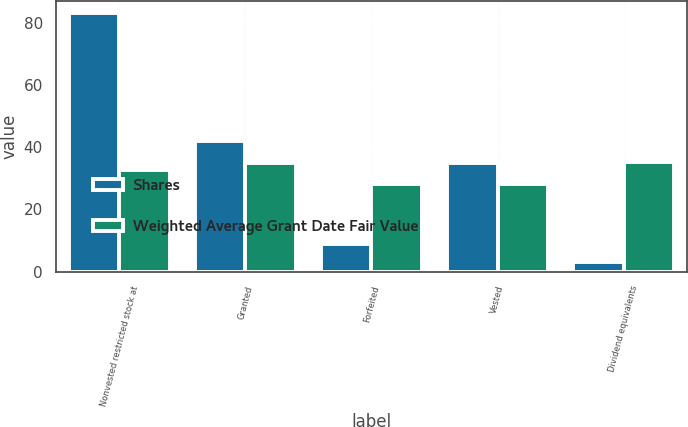Convert chart to OTSL. <chart><loc_0><loc_0><loc_500><loc_500><stacked_bar_chart><ecel><fcel>Nonvested restricted stock at<fcel>Granted<fcel>Forfeited<fcel>Vested<fcel>Dividend equivalents<nl><fcel>Shares<fcel>83<fcel>42<fcel>9<fcel>35<fcel>3<nl><fcel>Weighted Average Grant Date Fair Value<fcel>32.62<fcel>35<fcel>28.24<fcel>28.3<fcel>35.19<nl></chart> 